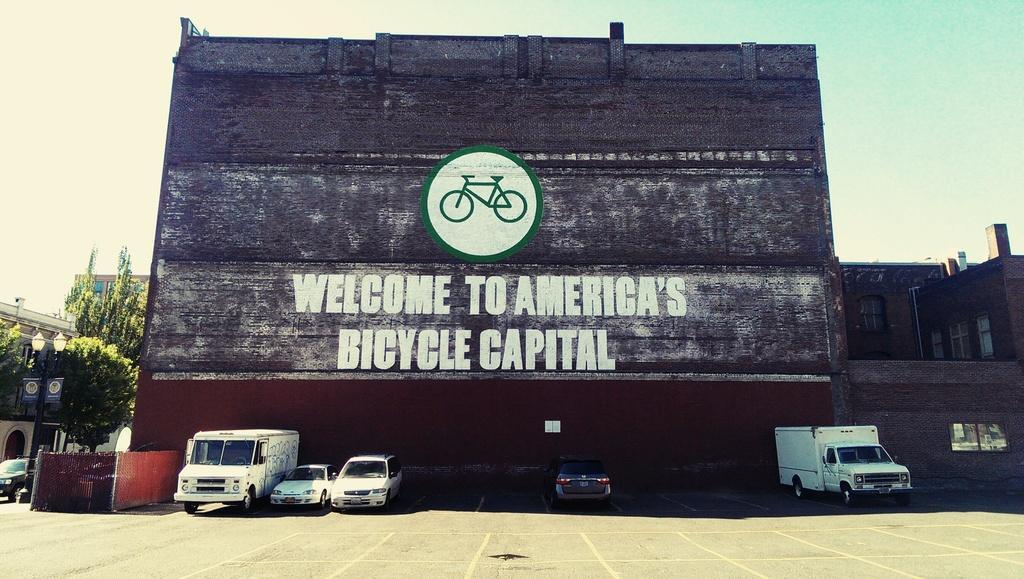Can you describe this image briefly? In the foreground I can see fleets of vehicles and a fence on the road. In the background I can see buildings, board, text, trees and the sky. This image is taken may be on the road. 